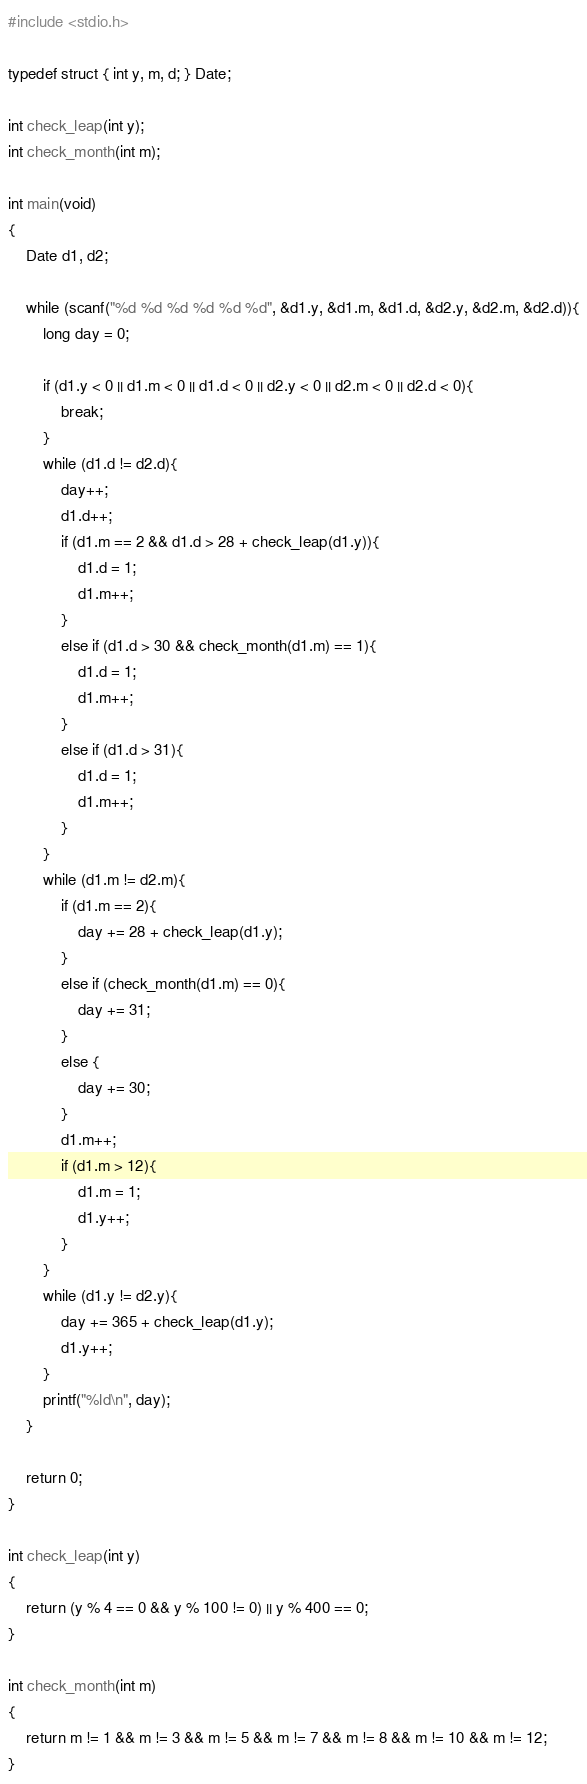<code> <loc_0><loc_0><loc_500><loc_500><_C_>#include <stdio.h>

typedef struct { int y, m, d; } Date;

int check_leap(int y);
int check_month(int m);

int main(void)
{
    Date d1, d2;
    
    while (scanf("%d %d %d %d %d %d", &d1.y, &d1.m, &d1.d, &d2.y, &d2.m, &d2.d)){
        long day = 0;
        
        if (d1.y < 0 || d1.m < 0 || d1.d < 0 || d2.y < 0 || d2.m < 0 || d2.d < 0){
            break;
        }
        while (d1.d != d2.d){
            day++;
            d1.d++;
            if (d1.m == 2 && d1.d > 28 + check_leap(d1.y)){
                d1.d = 1;
                d1.m++;
            }
            else if (d1.d > 30 && check_month(d1.m) == 1){
                d1.d = 1;
                d1.m++;
            }
            else if (d1.d > 31){
                d1.d = 1;
                d1.m++;
            }
        }
        while (d1.m != d2.m){
            if (d1.m == 2){
                day += 28 + check_leap(d1.y);
            }
            else if (check_month(d1.m) == 0){
                day += 31;
            }
            else {
                day += 30;
            }
            d1.m++;
            if (d1.m > 12){
                d1.m = 1;
                d1.y++;
            }
        }
        while (d1.y != d2.y){
            day += 365 + check_leap(d1.y);
            d1.y++;
        }
        printf("%ld\n", day);
    }
    
    return 0;
}

int check_leap(int y)
{
    return (y % 4 == 0 && y % 100 != 0) || y % 400 == 0;
}

int check_month(int m)
{
    return m != 1 && m != 3 && m != 5 && m != 7 && m != 8 && m != 10 && m != 12;
}</code> 